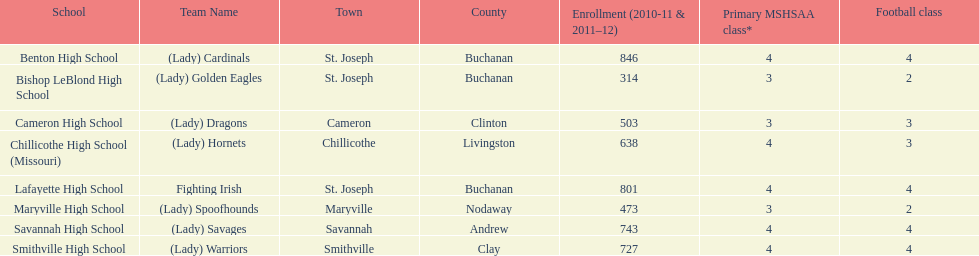Which schools are in the same town as bishop leblond? Benton High School, Lafayette High School. 